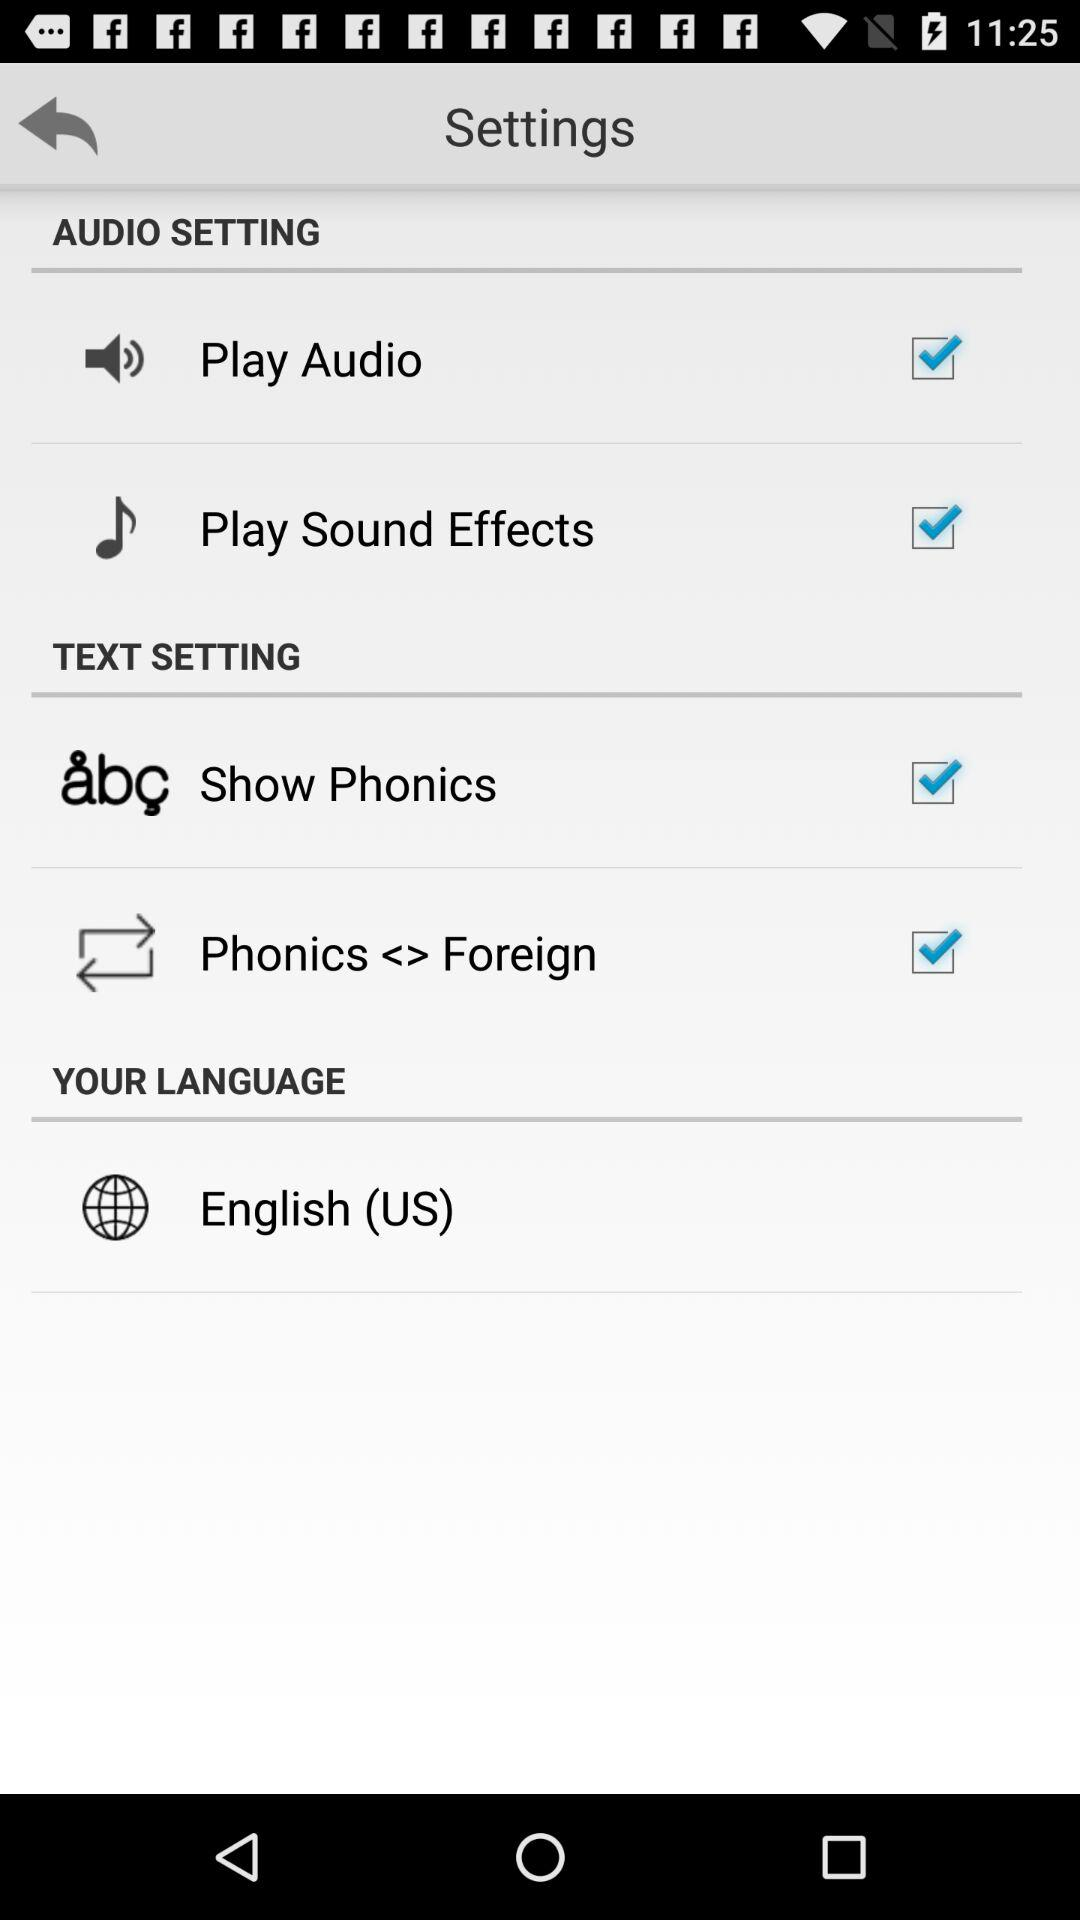What language is selected? The selected language is English (US). 